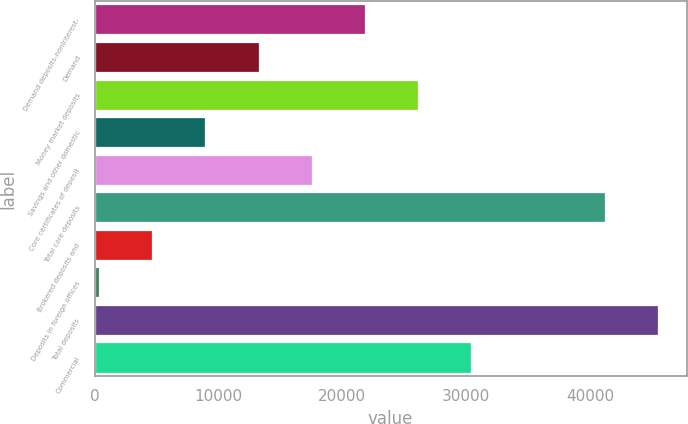Convert chart. <chart><loc_0><loc_0><loc_500><loc_500><bar_chart><fcel>Demand deposits-noninterest-<fcel>Demand<fcel>Money market deposits<fcel>Savings and other domestic<fcel>Core certificates of deposit<fcel>Total core deposits<fcel>Brokered deposits and<fcel>Deposits in foreign offices<fcel>Total deposits<fcel>Commercial<nl><fcel>21820.5<fcel>13236.7<fcel>26112.4<fcel>8944.8<fcel>17528.6<fcel>41208<fcel>4652.9<fcel>361<fcel>45499.9<fcel>30404.3<nl></chart> 